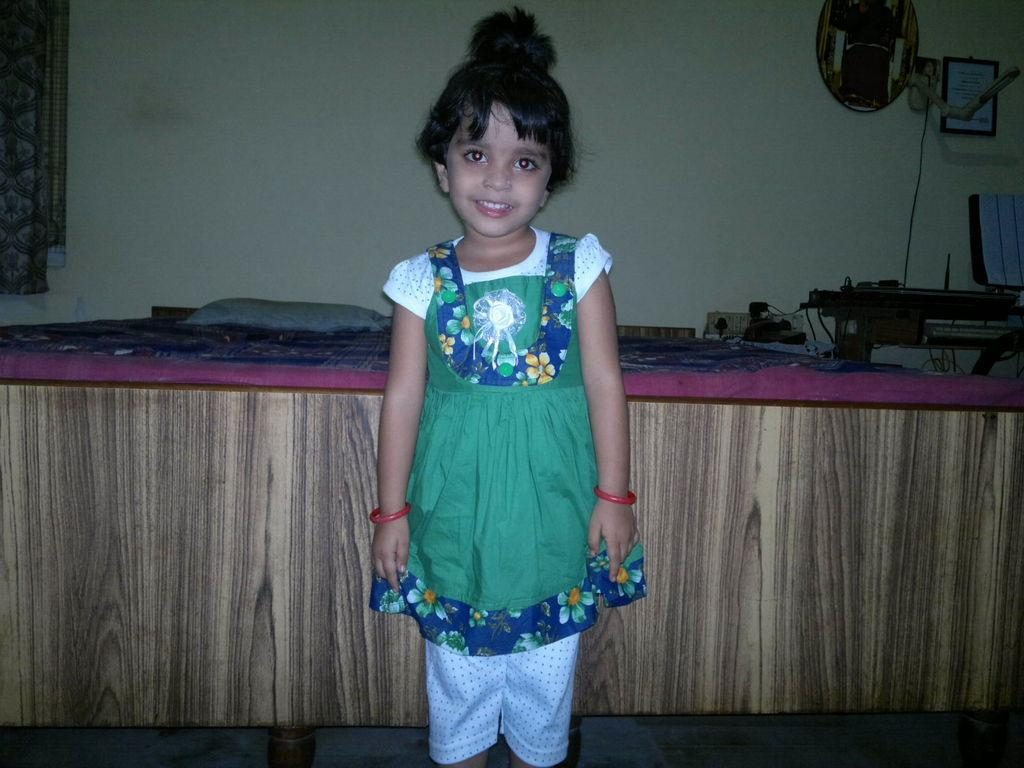What is the main subject of the image? There is a kid in the image. Where is the kid standing in relation to the bed? The kid is standing in front of a bed. What can be seen on the bed? There is a pillow on the bed. What is located beside the bed? There is a table beside the bed. What is placed on the table? There are things placed on the table. What type of zipper can be seen on the pillow in the image? There is no zipper present on the pillow in the image. What is the kid talking about in the image? The image does not provide any information about what the kid might be talking about. 